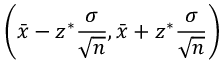Convert formula to latex. <formula><loc_0><loc_0><loc_500><loc_500>\left ( { \bar { x } } - z ^ { * } { \frac { \sigma } { \sqrt { n } } } , { \bar { x } } + z ^ { * } { \frac { \sigma } { \sqrt { n } } } \right )</formula> 